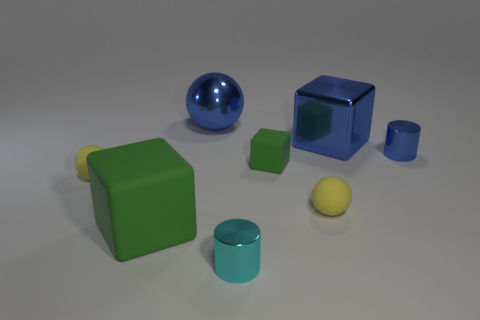Are the large green object and the tiny cylinder behind the small cyan cylinder made of the same material?
Keep it short and to the point. No. What number of metallic things are cyan cylinders or big green cylinders?
Provide a succinct answer. 1. What is the size of the sphere that is left of the big green matte block?
Make the answer very short. Small. There is a sphere that is the same material as the tiny blue cylinder; what size is it?
Provide a short and direct response. Large. What number of tiny objects have the same color as the large rubber cube?
Make the answer very short. 1. Are any small metallic objects visible?
Make the answer very short. Yes. Do the tiny blue metallic object and the cyan metal object in front of the large green rubber thing have the same shape?
Offer a terse response. Yes. What color is the cylinder to the left of the yellow sphere to the right of the big blue shiny object that is on the left side of the large metal block?
Your answer should be compact. Cyan. There is a big green thing; are there any big blocks behind it?
Give a very brief answer. Yes. There is a rubber object that is the same color as the small rubber cube; what size is it?
Provide a short and direct response. Large. 